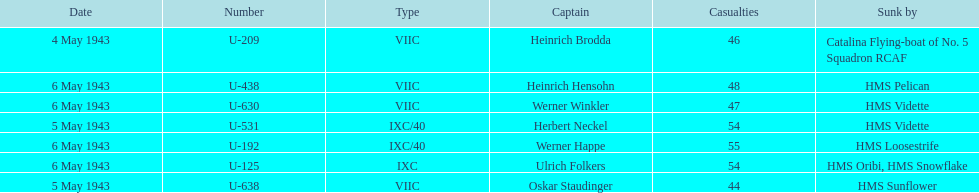How many more casualties occurred on may 6 compared to may 4? 158. 